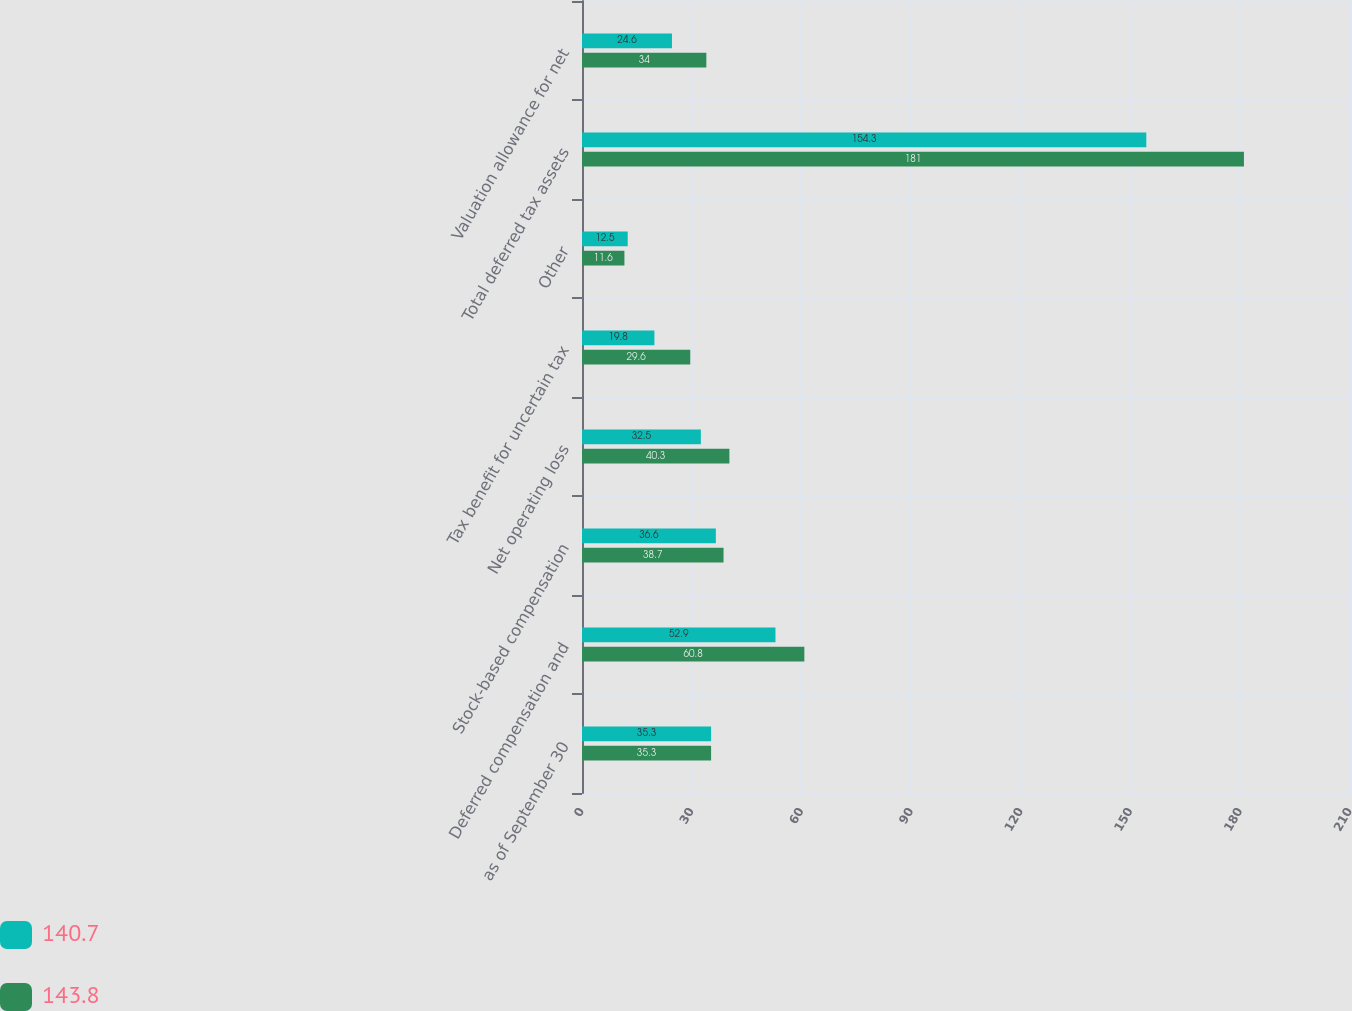Convert chart. <chart><loc_0><loc_0><loc_500><loc_500><stacked_bar_chart><ecel><fcel>as of September 30<fcel>Deferred compensation and<fcel>Stock-based compensation<fcel>Net operating loss<fcel>Tax benefit for uncertain tax<fcel>Other<fcel>Total deferred tax assets<fcel>Valuation allowance for net<nl><fcel>140.7<fcel>35.3<fcel>52.9<fcel>36.6<fcel>32.5<fcel>19.8<fcel>12.5<fcel>154.3<fcel>24.6<nl><fcel>143.8<fcel>35.3<fcel>60.8<fcel>38.7<fcel>40.3<fcel>29.6<fcel>11.6<fcel>181<fcel>34<nl></chart> 